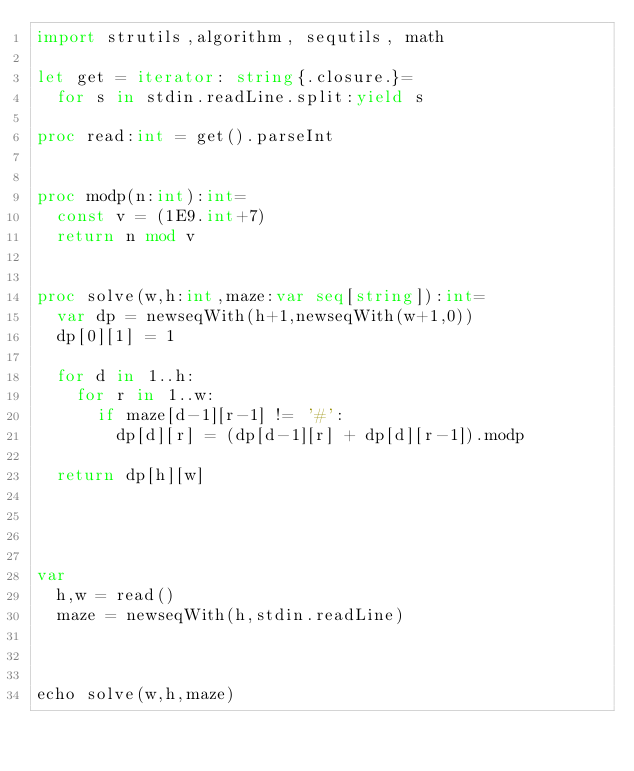Convert code to text. <code><loc_0><loc_0><loc_500><loc_500><_Nim_>import strutils,algorithm, sequtils, math

let get = iterator: string{.closure.}=
  for s in stdin.readLine.split:yield s

proc read:int = get().parseInt


proc modp(n:int):int=
  const v = (1E9.int+7)
  return n mod v


proc solve(w,h:int,maze:var seq[string]):int=
  var dp = newseqWith(h+1,newseqWith(w+1,0))
  dp[0][1] = 1
  
  for d in 1..h:
    for r in 1..w:
      if maze[d-1][r-1] != '#':
        dp[d][r] = (dp[d-1][r] + dp[d][r-1]).modp
  
  return dp[h][w]




var
  h,w = read()
  maze = newseqWith(h,stdin.readLine)



echo solve(w,h,maze)


</code> 